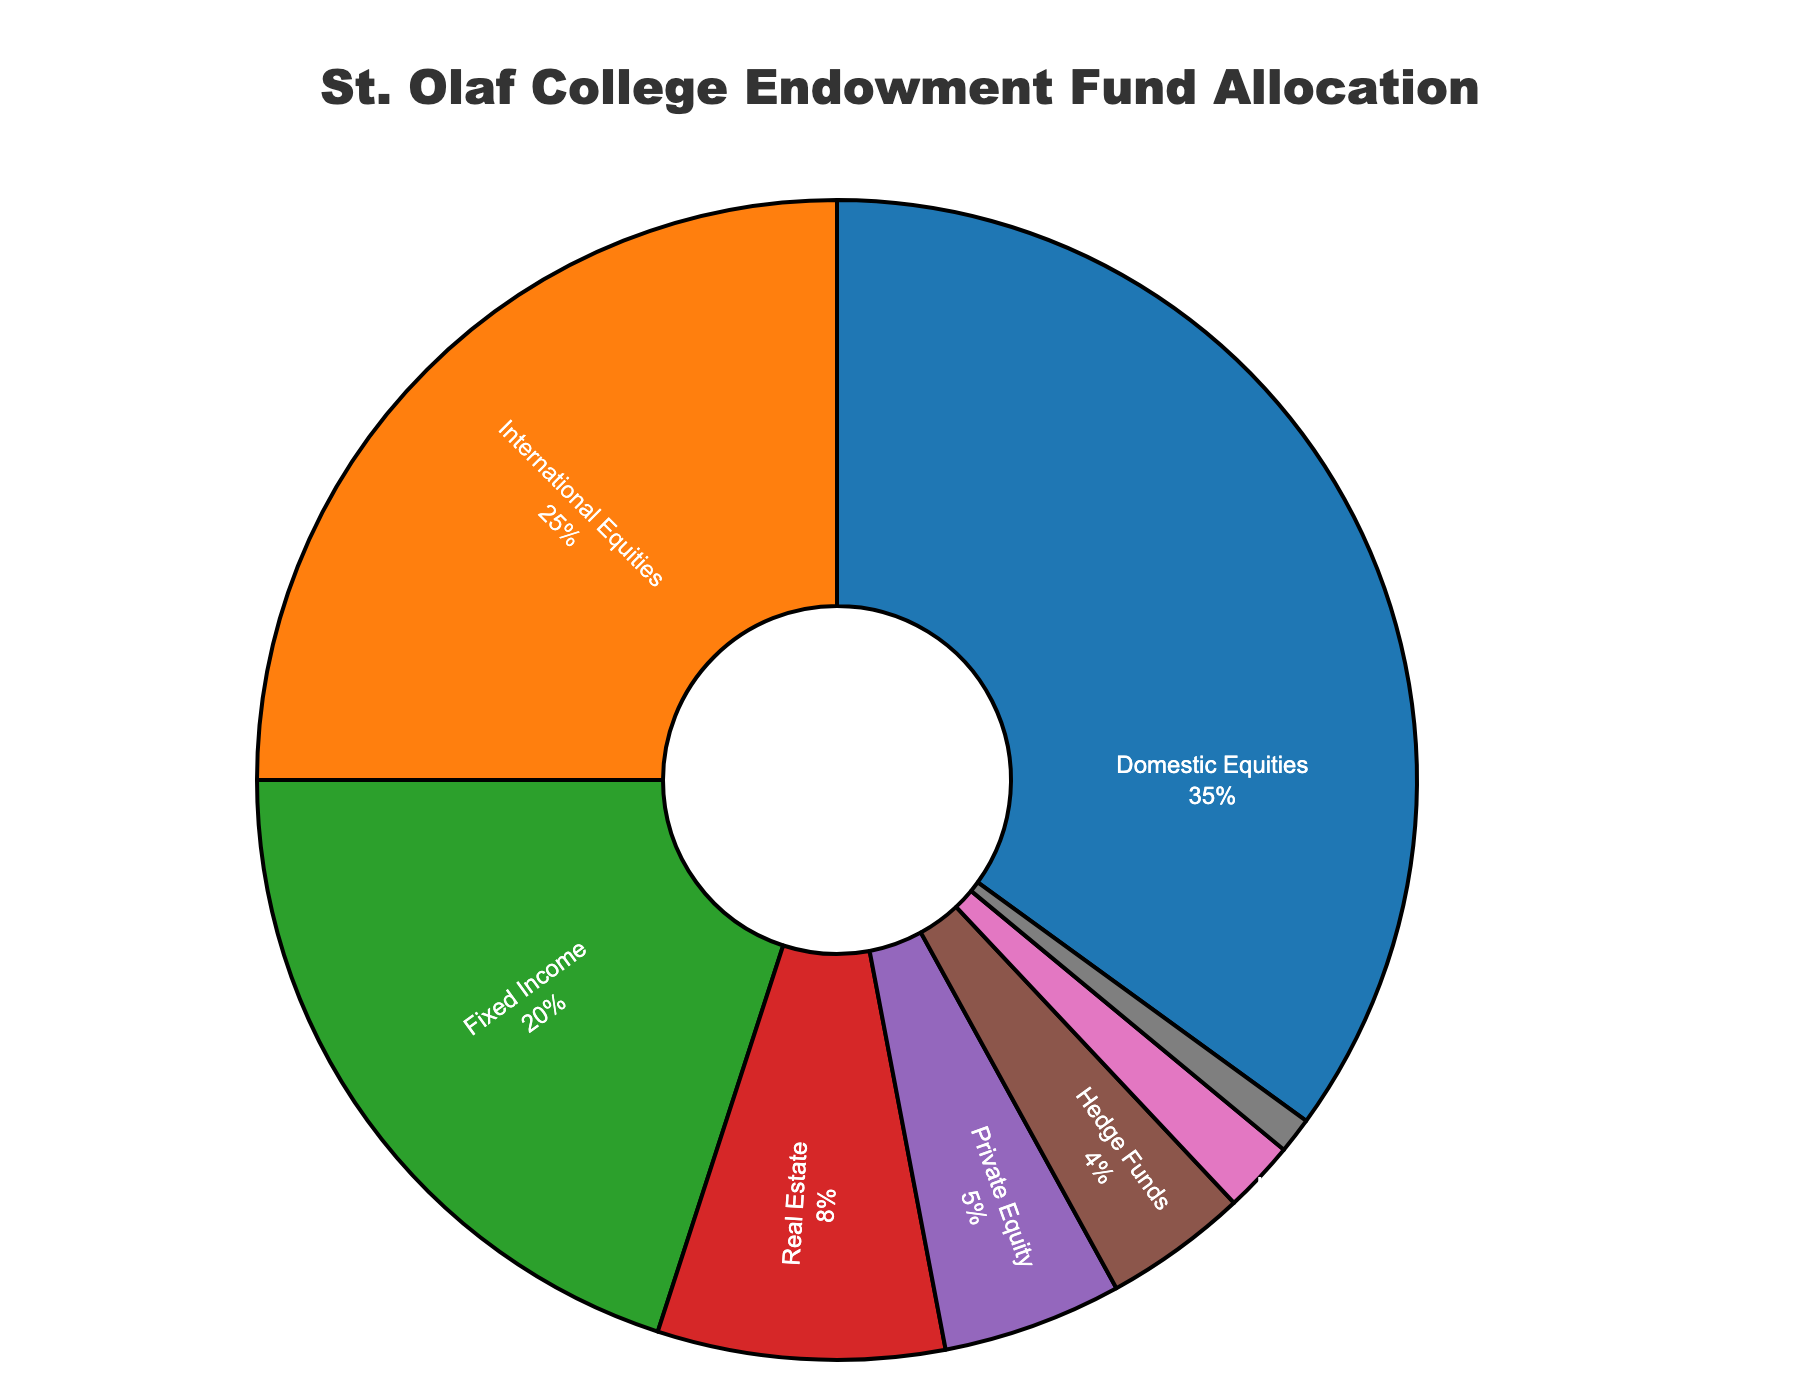What's the largest allocation in St. Olaf College's endowment fund? Look at the sectors on the pie chart. The largest segment will represent the biggest allocation. Domestic Equities has the largest slice.
Answer: Domestic Equities Which two categories form exactly 60% of the endowment fund? Add up different slices' percentages. Domestic Equities (35%) + International Equities (25%) = 60%.
Answer: Domestic Equities and International Equities How much larger is the allocation for Fixed Income compared to Real Estate? Subtract the percentage of Real Estate from the percentage of Fixed Income. Fixed Income (20%) - Real Estate (8%) = 12%.
Answer: 12% What is the combined allocation of Private Equity and Hedge Funds? Add the percentages of Private Equity and Hedge Funds. Private Equity (5%) + Hedge Funds (4%) = 9%.
Answer: 9% Which category has the smallest allocation, and what is its percentage? Identify the smallest segment in the pie chart. Cash and Equivalents is the smallest, with 1%.
Answer: Cash and Equivalents, 1% What is the combined allocation of Natural Resources, Real Estate, and Private Equity? Add the percentages of Natural Resources, Real Estate, and Private Equity. 2% (Natural Resources) + 8% (Real Estate) + 5% (Private Equity) = 15%.
Answer: 15% Is the allocation for Hedge Funds greater or less than the combined allocation of Natural Resources and Cash and Equivalents? Compare Hedge Funds (4%) with the sum of Natural Resources and Cash and Equivalents (2% + 1%). Hedge Funds (4%) is greater.
Answer: Greater Which category follows immediately after Domestic Equities in terms of allocation size? Look at the second-largest segment in the pie chart. International Equities comes after Domestic Equities with 25%.
Answer: International Equities What is the combined percentage of all non-equity categories in the endowment fund? Add the percentages of Fixed Income, Real Estate, Private Equity, Hedge Funds, Natural Resources, and Cash and Equivalents. 20% + 8% + 5% + 4% + 2% + 1% = 40%.
Answer: 40% How many categories have allocations less than 10%? Count the segments with percentages under 10%. Real Estate (8%), Private Equity (5%), Hedge Funds (4%), Natural Resources (2%), and Cash and Equivalents (1%) make 5 categories.
Answer: 5 categories 